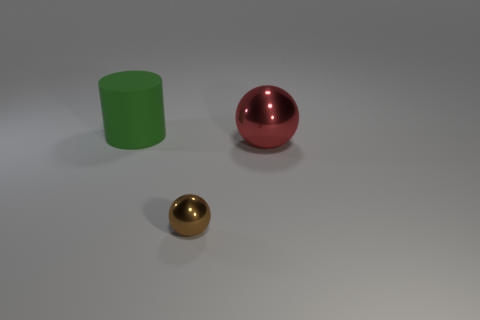Are there any other things that have the same material as the cylinder?
Provide a succinct answer. No. There is a sphere that is behind the sphere in front of the large thing in front of the matte thing; what is its color?
Ensure brevity in your answer.  Red. There is another brown thing that is the same shape as the big shiny thing; what is it made of?
Give a very brief answer. Metal. What is the color of the big metallic sphere?
Your response must be concise. Red. Is the color of the small thing the same as the big cylinder?
Offer a terse response. No. What number of rubber things are either balls or large green objects?
Your answer should be very brief. 1. Are there any large green objects on the right side of the shiny sphere that is on the left side of the large object in front of the big green thing?
Give a very brief answer. No. The other ball that is made of the same material as the tiny sphere is what size?
Offer a terse response. Large. There is a tiny brown object; are there any big red objects to the left of it?
Keep it short and to the point. No. There is a large object in front of the big matte cylinder; is there a big green rubber thing in front of it?
Your answer should be compact. No. 